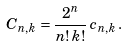Convert formula to latex. <formula><loc_0><loc_0><loc_500><loc_500>C _ { n , k } = \frac { 2 ^ { n } } { n ! \, k ! } \, c _ { n , k } \, .</formula> 